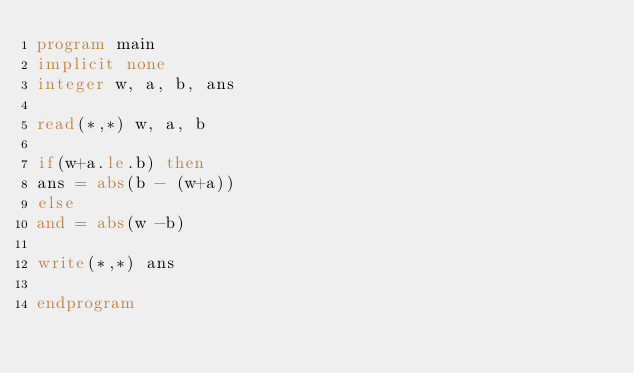Convert code to text. <code><loc_0><loc_0><loc_500><loc_500><_FORTRAN_>program main
implicit none
integer w, a, b, ans

read(*,*) w, a, b

if(w+a.le.b) then
ans = abs(b - (w+a))
else
and = abs(w -b)

write(*,*) ans

endprogram</code> 